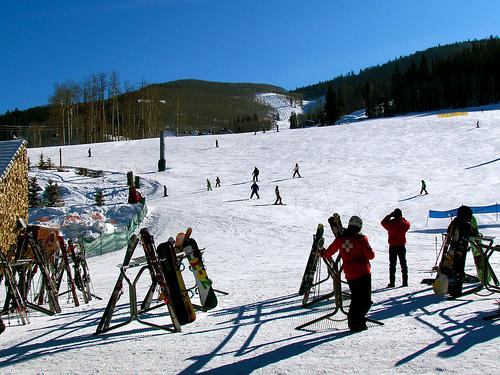Describe the activity taking place on the ski slope. Multiple people are skiing or snowboarding on the snowy ski slope, some close to trees and others closer to the rack of skis and snowboards. Write about the walls and buildings in the image. A brown building is near people, and there's a green wall near it. Several walls on the sides of buildings are also noticeable. Explain the scene when referring to a person in dark pants. A person wearing dark pants is standing in the snow, close to skiers and a rack of snowboards and skis. What is the most noticeable feature of the person wearing a red winter jacket? The person in the red winter jacket is leaning on a rack of skis. Describe the setting of the image in a few words. The image is set on a snowy ski slope, featuring skiers, a rack of snowboards and skis, and tall trees. Mention a significant tree feature in the image. There is a tall, leafless brown tree bordering the white snow as a significant feature. Identify the color and quality of the sky in the image. The sky in the image is blue and clear, with no clouds present. 